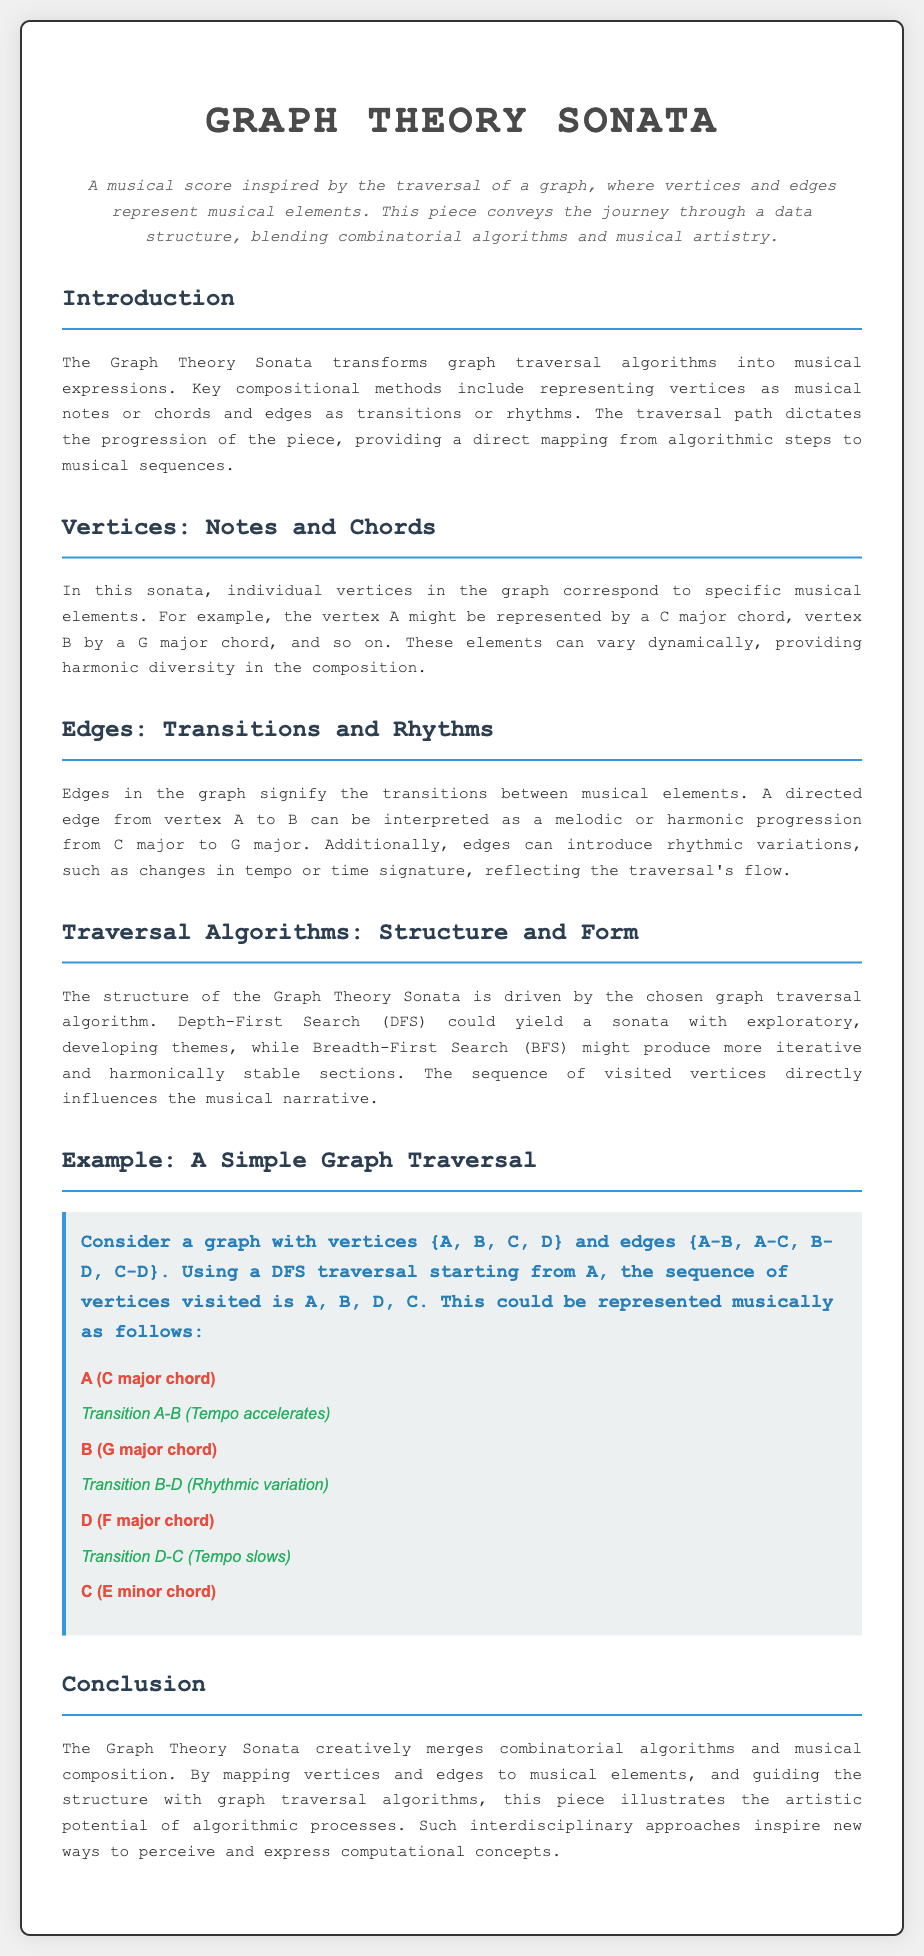What is the title of the piece? The title is mentioned prominently at the top of the document.
Answer: Graph Theory Sonata What do the vertices represent in the sonata? The document specifies that vertices correspond to musical elements.
Answer: Musical elements Which chord represents vertex A? The document details what chord corresponds to each vertex, starting with vertex A.
Answer: C major chord What type of traversal algorithm could yield exploratory themes? The section discusses how different algorithms affect the structure, focusing on DFS.
Answer: Depth-First Search (DFS) In the example graph, what is the last vertex visited? The traversal sequence is outlined clearly in the example section.
Answer: C What is the main artistic inspiration behind the Graph Theory Sonata? The introduction highlights the key concept that drives the piece.
Answer: Graph traversal algorithms How many vertices are mentioned in the example graph? The example explicitly states the number of vertices in the graph presented.
Answer: Four What type of transition occurs from A to B? The transitions are described in relation to musical elements during traversal.
Answer: Tempo accelerates What is emphasized in the conclusion regarding the Graph Theory Sonata? The conclusion summarizes the integrative concepts of the piece.
Answer: Interdisciplinary approaches 